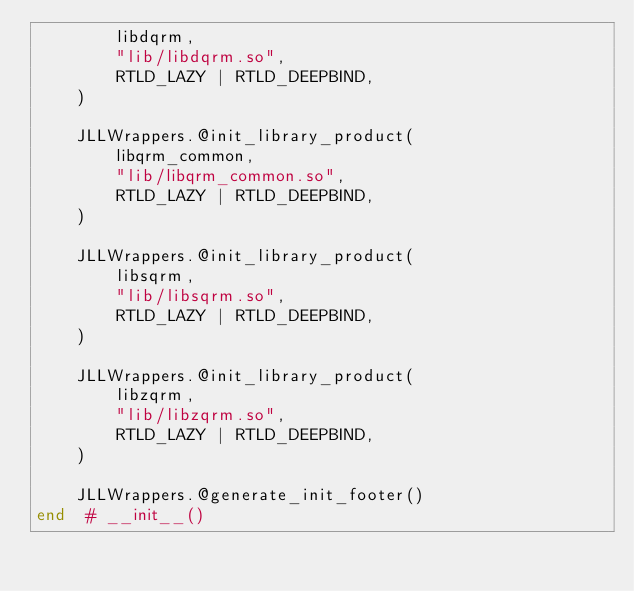Convert code to text. <code><loc_0><loc_0><loc_500><loc_500><_Julia_>        libdqrm,
        "lib/libdqrm.so",
        RTLD_LAZY | RTLD_DEEPBIND,
    )

    JLLWrappers.@init_library_product(
        libqrm_common,
        "lib/libqrm_common.so",
        RTLD_LAZY | RTLD_DEEPBIND,
    )

    JLLWrappers.@init_library_product(
        libsqrm,
        "lib/libsqrm.so",
        RTLD_LAZY | RTLD_DEEPBIND,
    )

    JLLWrappers.@init_library_product(
        libzqrm,
        "lib/libzqrm.so",
        RTLD_LAZY | RTLD_DEEPBIND,
    )

    JLLWrappers.@generate_init_footer()
end  # __init__()
</code> 